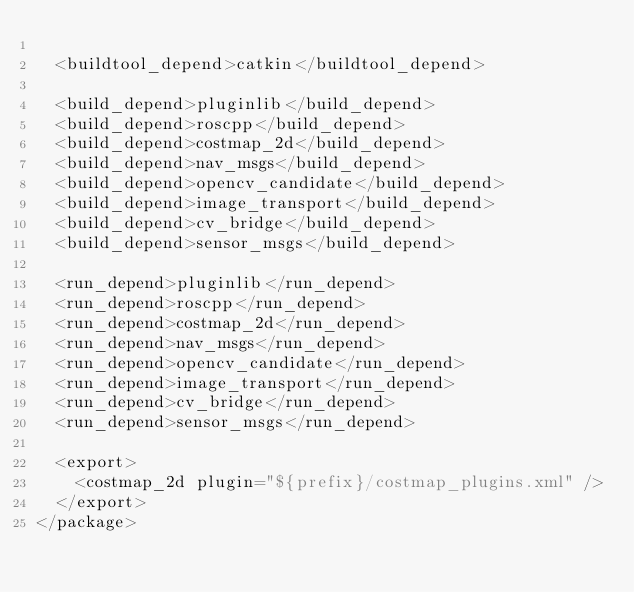<code> <loc_0><loc_0><loc_500><loc_500><_XML_>
  <buildtool_depend>catkin</buildtool_depend>
  
  <build_depend>pluginlib</build_depend>
  <build_depend>roscpp</build_depend>
  <build_depend>costmap_2d</build_depend>
  <build_depend>nav_msgs</build_depend>
  <build_depend>opencv_candidate</build_depend>
  <build_depend>image_transport</build_depend>
  <build_depend>cv_bridge</build_depend>
  <build_depend>sensor_msgs</build_depend>

  <run_depend>pluginlib</run_depend>
  <run_depend>roscpp</run_depend>
  <run_depend>costmap_2d</run_depend>
  <run_depend>nav_msgs</run_depend>
  <run_depend>opencv_candidate</run_depend>
  <run_depend>image_transport</run_depend>
  <run_depend>cv_bridge</run_depend>
  <run_depend>sensor_msgs</run_depend>

  <export>
    <costmap_2d plugin="${prefix}/costmap_plugins.xml" />
  </export>
</package>
</code> 